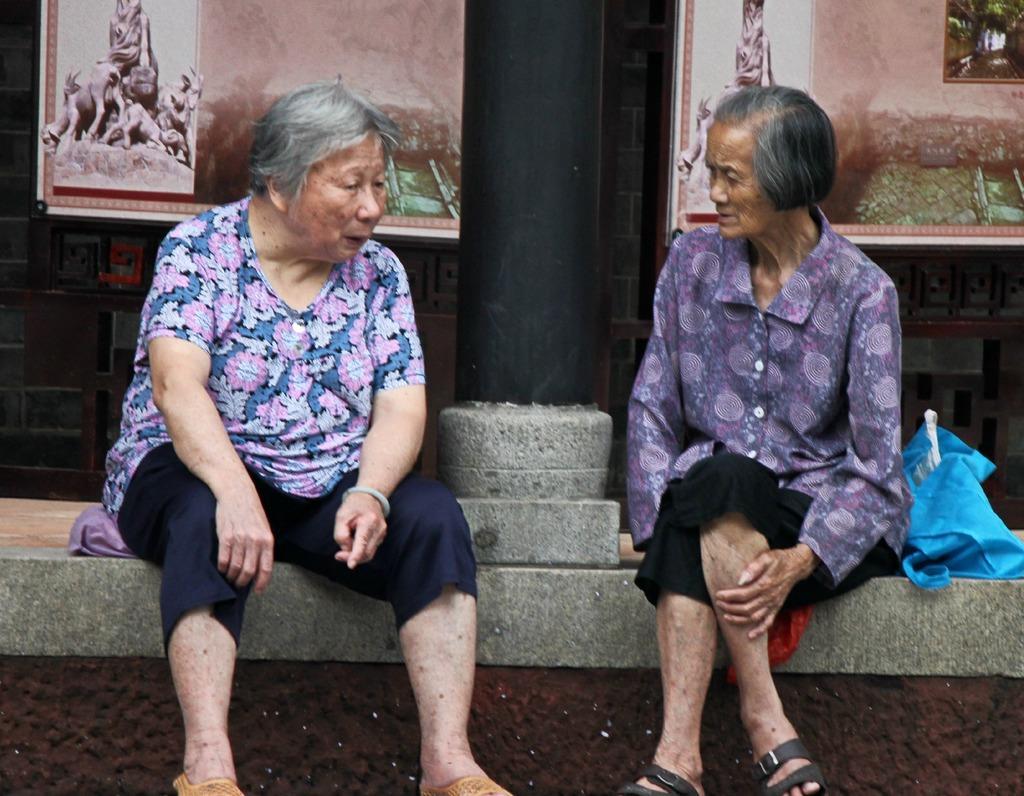In one or two sentences, can you explain what this image depicts? In this picture there are two persons sitting on the wall. In the middle there is a pillar. At the back there are frames on the wall. On the right side of the image there is a bag on the wall. 